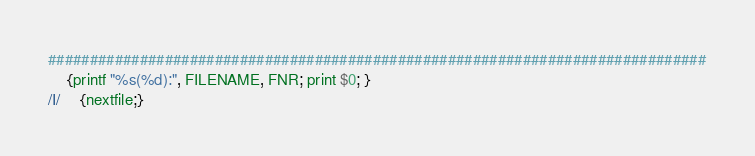Convert code to text. <code><loc_0><loc_0><loc_500><loc_500><_Awk_>###############################################################################
	{printf "%s(%d):", FILENAME, FNR; print $0; }
/I/	{nextfile;}
</code> 